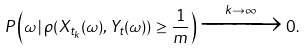<formula> <loc_0><loc_0><loc_500><loc_500>P \left ( \omega \, | \, \rho ( X _ { t _ { k } } ( \omega ) , Y _ { t } ( \omega ) ) \geq \frac { 1 } { m } \right ) \xrightarrow { k \to \infty } 0 .</formula> 